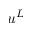<formula> <loc_0><loc_0><loc_500><loc_500>u ^ { L }</formula> 